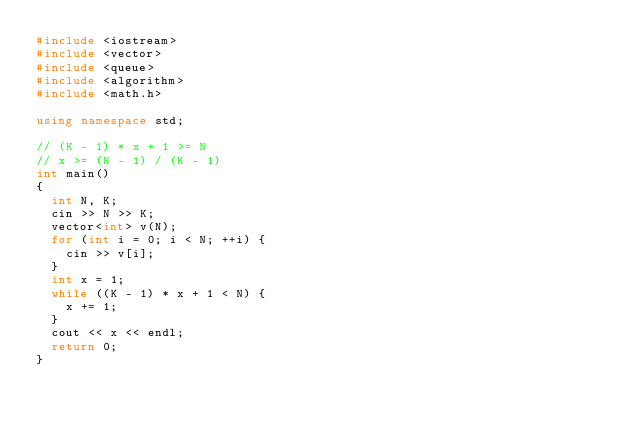Convert code to text. <code><loc_0><loc_0><loc_500><loc_500><_C++_>#include <iostream>
#include <vector>
#include <queue>
#include <algorithm>
#include <math.h>

using namespace std;

// (K - 1) * x + 1 >= N
// x >= (N - 1) / (K - 1)
int main()
{
  int N, K;
  cin >> N >> K;
  vector<int> v(N);
  for (int i = 0; i < N; ++i) {
    cin >> v[i];
  }
  int x = 1;
  while ((K - 1) * x + 1 < N) {
    x += 1;
  }
  cout << x << endl;
  return 0;
}
</code> 